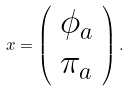<formula> <loc_0><loc_0><loc_500><loc_500>x = \left ( \begin{array} { c } \phi _ { a } \\ \pi _ { a } \end{array} \right ) .</formula> 